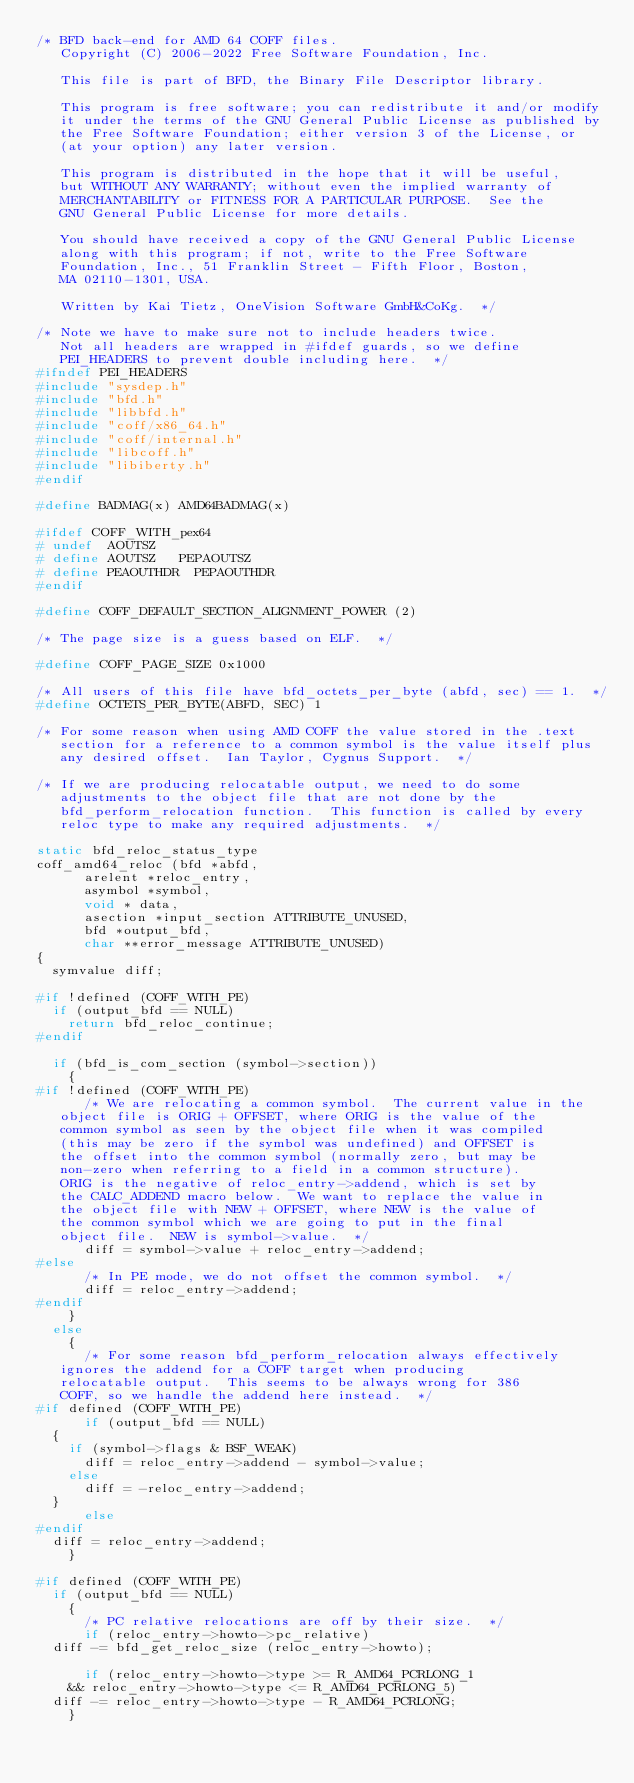Convert code to text. <code><loc_0><loc_0><loc_500><loc_500><_C_>/* BFD back-end for AMD 64 COFF files.
   Copyright (C) 2006-2022 Free Software Foundation, Inc.

   This file is part of BFD, the Binary File Descriptor library.

   This program is free software; you can redistribute it and/or modify
   it under the terms of the GNU General Public License as published by
   the Free Software Foundation; either version 3 of the License, or
   (at your option) any later version.

   This program is distributed in the hope that it will be useful,
   but WITHOUT ANY WARRANTY; without even the implied warranty of
   MERCHANTABILITY or FITNESS FOR A PARTICULAR PURPOSE.  See the
   GNU General Public License for more details.

   You should have received a copy of the GNU General Public License
   along with this program; if not, write to the Free Software
   Foundation, Inc., 51 Franklin Street - Fifth Floor, Boston,
   MA 02110-1301, USA.

   Written by Kai Tietz, OneVision Software GmbH&CoKg.  */

/* Note we have to make sure not to include headers twice.
   Not all headers are wrapped in #ifdef guards, so we define
   PEI_HEADERS to prevent double including here.  */
#ifndef PEI_HEADERS
#include "sysdep.h"
#include "bfd.h"
#include "libbfd.h"
#include "coff/x86_64.h"
#include "coff/internal.h"
#include "libcoff.h"
#include "libiberty.h"
#endif

#define BADMAG(x) AMD64BADMAG(x)

#ifdef COFF_WITH_pex64
# undef  AOUTSZ
# define AOUTSZ		PEPAOUTSZ
# define PEAOUTHDR	PEPAOUTHDR
#endif

#define COFF_DEFAULT_SECTION_ALIGNMENT_POWER (2)

/* The page size is a guess based on ELF.  */

#define COFF_PAGE_SIZE 0x1000

/* All users of this file have bfd_octets_per_byte (abfd, sec) == 1.  */
#define OCTETS_PER_BYTE(ABFD, SEC) 1

/* For some reason when using AMD COFF the value stored in the .text
   section for a reference to a common symbol is the value itself plus
   any desired offset.  Ian Taylor, Cygnus Support.  */

/* If we are producing relocatable output, we need to do some
   adjustments to the object file that are not done by the
   bfd_perform_relocation function.  This function is called by every
   reloc type to make any required adjustments.  */

static bfd_reloc_status_type
coff_amd64_reloc (bfd *abfd,
		  arelent *reloc_entry,
		  asymbol *symbol,
		  void * data,
		  asection *input_section ATTRIBUTE_UNUSED,
		  bfd *output_bfd,
		  char **error_message ATTRIBUTE_UNUSED)
{
  symvalue diff;

#if !defined (COFF_WITH_PE)
  if (output_bfd == NULL)
    return bfd_reloc_continue;
#endif

  if (bfd_is_com_section (symbol->section))
    {
#if !defined (COFF_WITH_PE)
      /* We are relocating a common symbol.  The current value in the
	 object file is ORIG + OFFSET, where ORIG is the value of the
	 common symbol as seen by the object file when it was compiled
	 (this may be zero if the symbol was undefined) and OFFSET is
	 the offset into the common symbol (normally zero, but may be
	 non-zero when referring to a field in a common structure).
	 ORIG is the negative of reloc_entry->addend, which is set by
	 the CALC_ADDEND macro below.  We want to replace the value in
	 the object file with NEW + OFFSET, where NEW is the value of
	 the common symbol which we are going to put in the final
	 object file.  NEW is symbol->value.  */
      diff = symbol->value + reloc_entry->addend;
#else
      /* In PE mode, we do not offset the common symbol.  */
      diff = reloc_entry->addend;
#endif
    }
  else
    {
      /* For some reason bfd_perform_relocation always effectively
	 ignores the addend for a COFF target when producing
	 relocatable output.  This seems to be always wrong for 386
	 COFF, so we handle the addend here instead.  */
#if defined (COFF_WITH_PE)
      if (output_bfd == NULL)
	{
	  if (symbol->flags & BSF_WEAK)
	    diff = reloc_entry->addend - symbol->value;
	  else
	    diff = -reloc_entry->addend;
	}
      else
#endif
	diff = reloc_entry->addend;
    }

#if defined (COFF_WITH_PE)
  if (output_bfd == NULL)
    {
      /* PC relative relocations are off by their size.  */
      if (reloc_entry->howto->pc_relative)
	diff -= bfd_get_reloc_size (reloc_entry->howto);

      if (reloc_entry->howto->type >= R_AMD64_PCRLONG_1
	  && reloc_entry->howto->type <= R_AMD64_PCRLONG_5)
	diff -= reloc_entry->howto->type - R_AMD64_PCRLONG;
    }
</code> 